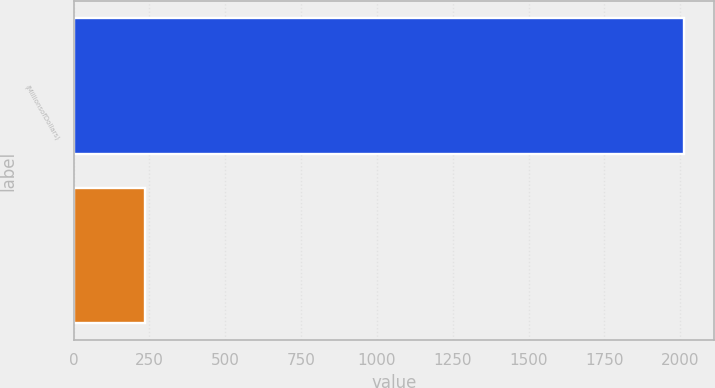Convert chart to OTSL. <chart><loc_0><loc_0><loc_500><loc_500><bar_chart><fcel>(MillionsofDollars)<fcel>Unnamed: 1<nl><fcel>2011<fcel>235.93<nl></chart> 